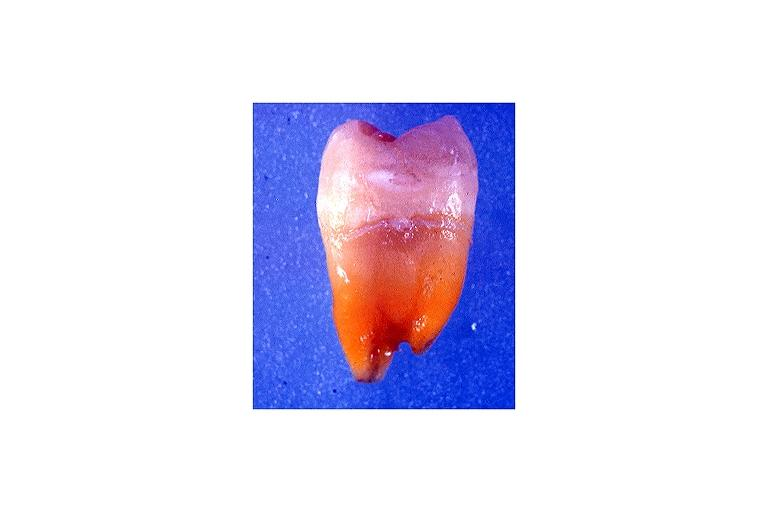does this image show tetracycline induced discoloration?
Answer the question using a single word or phrase. Yes 